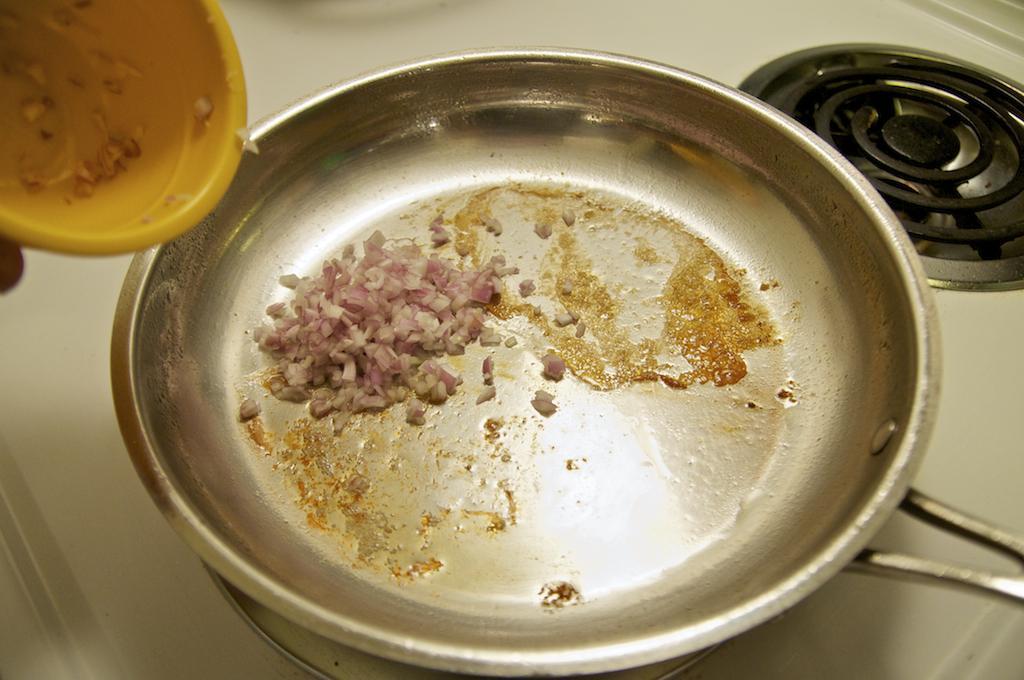Describe this image in one or two sentences. In this picture I can see a pan on the stove in the middle, in the top left hand side there is a plastic bowl. 